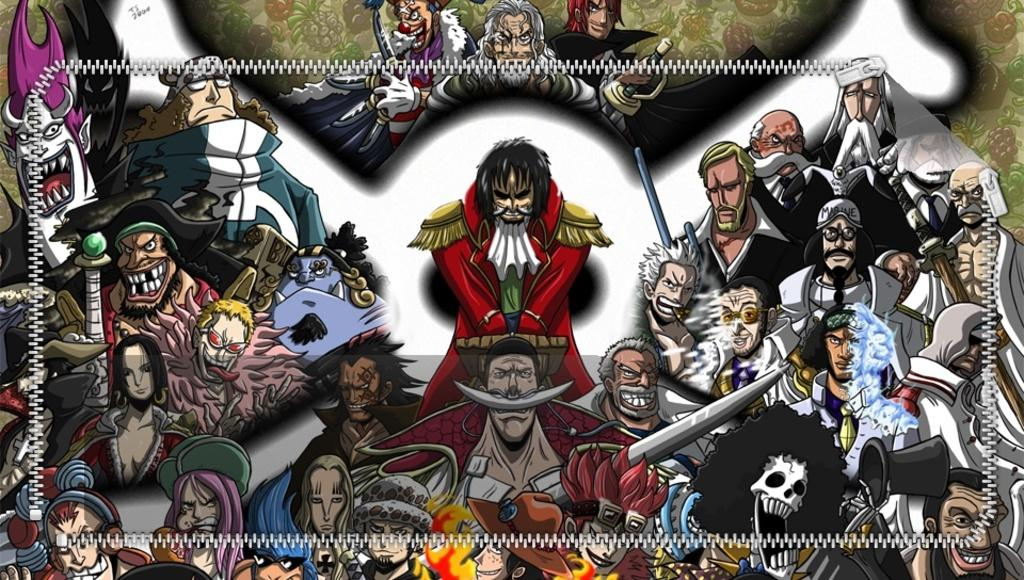What is the main subject of the image? There are depictions of persons in the center of the image. What type of rainstorm can be seen in the image? There is no rainstorm present in the image; it features depictions of persons. What type of vehicle is the achiever driving in the image? There is no achiever or vehicle present in the image; it only features depictions of persons. 